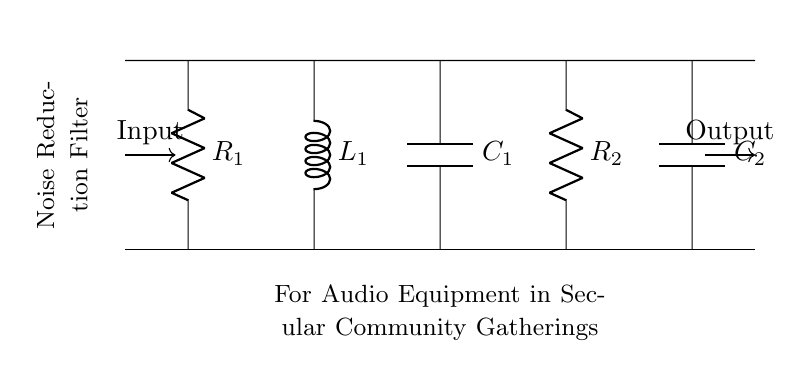What are the component types in this circuit? The circuit consists of resistors, an inductor, and capacitors, which are the typical components of a resistor-inductor-capacitor circuit.
Answer: Resistors, inductor, capacitors What connects the input to the output? A combination of resistors, an inductor, and capacitors serves as the pathway for the input signal to travel through before reaching the output.
Answer: Resistor-inductor-capacitor network How many capacitors are in the circuit? There are two capacitors, as indicated by the labels C1 and C2 in the circuit diagram.
Answer: Two What is the purpose of the inductor in this circuit? The inductor typically functions to filter out high-frequency signals, allowing the circuit to reduce noise and maintain audio quality.
Answer: Noise filtering What is the total impedance for this configuration at high frequencies? At high frequencies, the impedance will predominantly be determined by the capacitors, as inductors tend to act as short circuits. Therefore, the total impedance is low.
Answer: Low impedance What type of filter does this circuit represent? The configuration of resistors, capacitors, and an inductor indicates a low-pass filter, which allows lower frequency signals to pass while attenuating higher frequencies.
Answer: Low-pass filter 